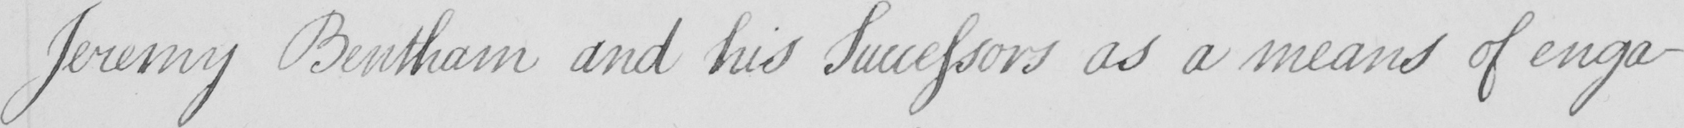Can you read and transcribe this handwriting? Jeremy Bentham and his Successors as a means of enga- 